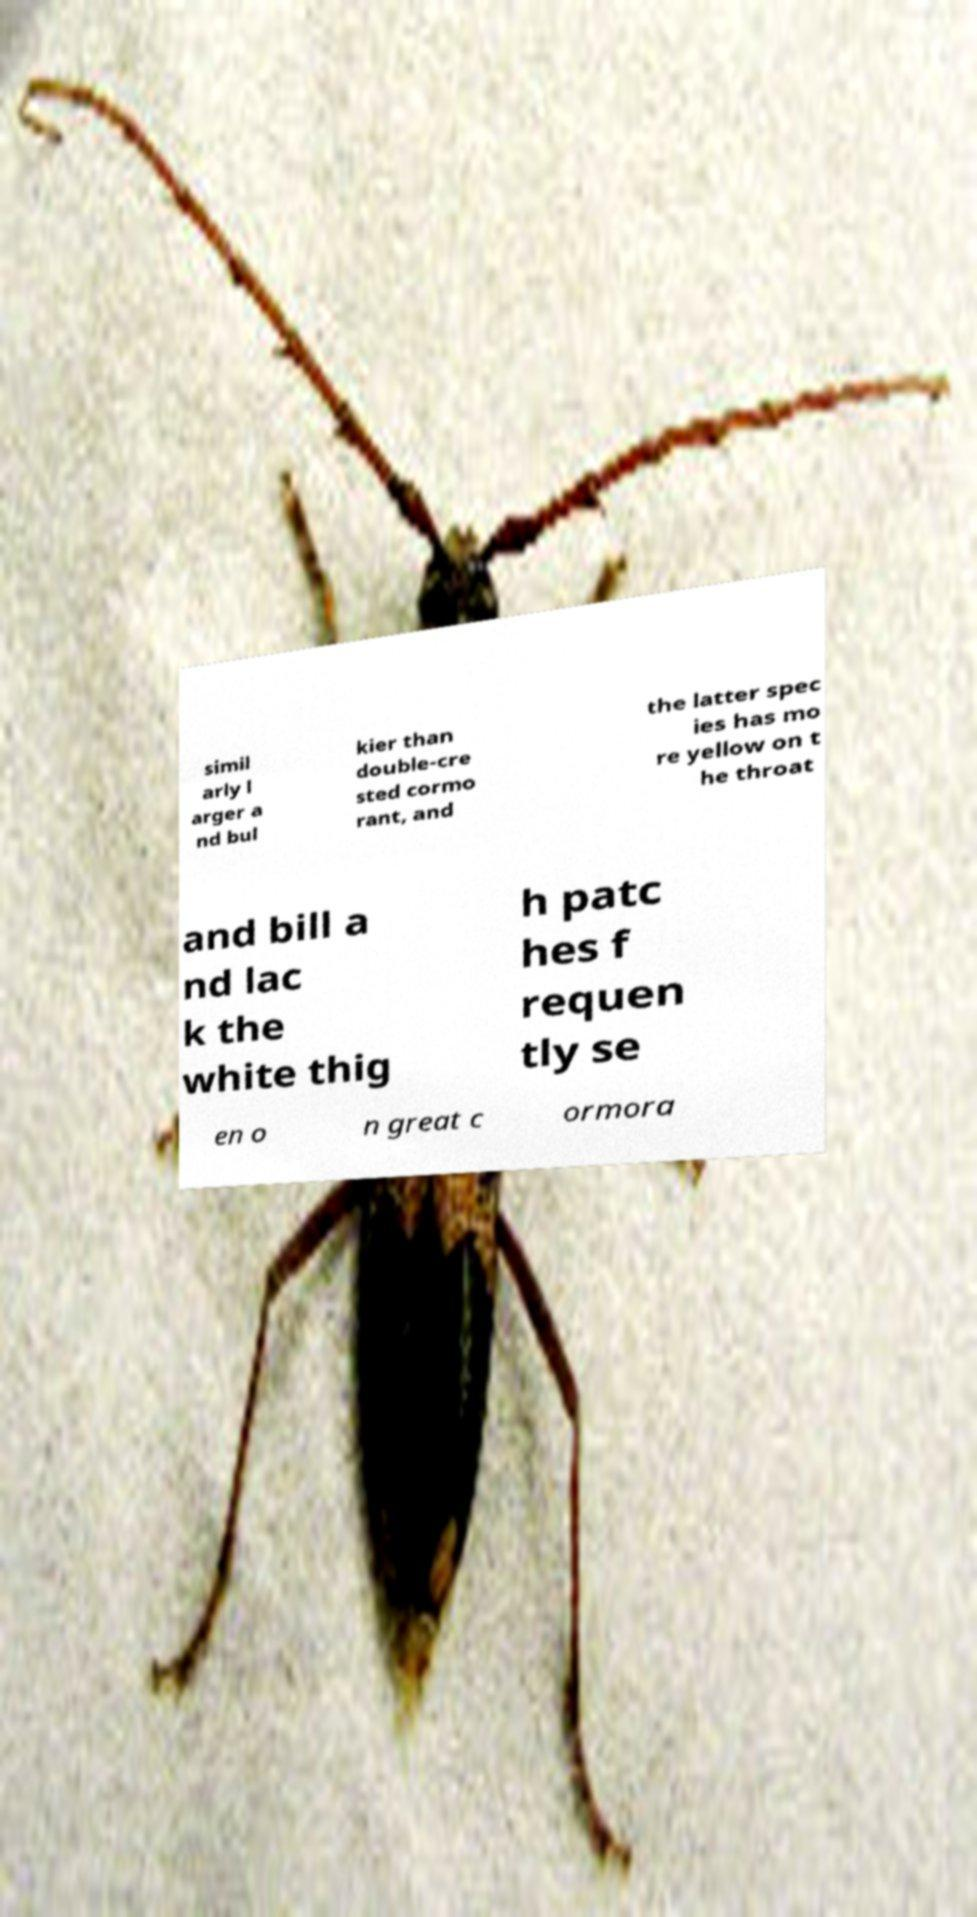There's text embedded in this image that I need extracted. Can you transcribe it verbatim? simil arly l arger a nd bul kier than double-cre sted cormo rant, and the latter spec ies has mo re yellow on t he throat and bill a nd lac k the white thig h patc hes f requen tly se en o n great c ormora 